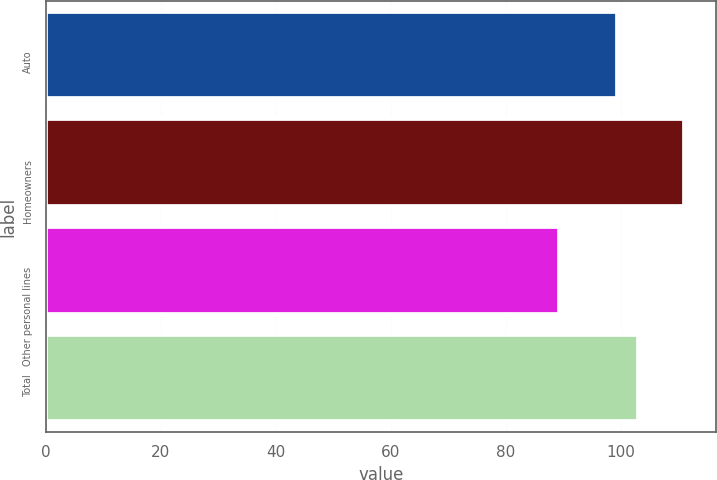Convert chart. <chart><loc_0><loc_0><loc_500><loc_500><bar_chart><fcel>Auto<fcel>Homeowners<fcel>Other personal lines<fcel>Total<nl><fcel>99.3<fcel>110.9<fcel>89.2<fcel>103<nl></chart> 